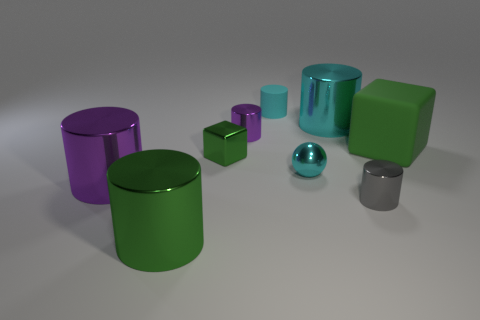How many green cubes must be subtracted to get 1 green cubes? 1 Subtract all green cylinders. How many cylinders are left? 5 Subtract all big cyan metallic cylinders. How many cylinders are left? 5 Subtract all gray cylinders. Subtract all cyan cubes. How many cylinders are left? 5 Subtract all brown cubes. How many green cylinders are left? 1 Add 1 big matte cubes. How many objects exist? 10 Subtract 0 blue cylinders. How many objects are left? 9 Subtract all cubes. How many objects are left? 7 Subtract 1 cubes. How many cubes are left? 1 Subtract all small cyan metal spheres. Subtract all small green objects. How many objects are left? 7 